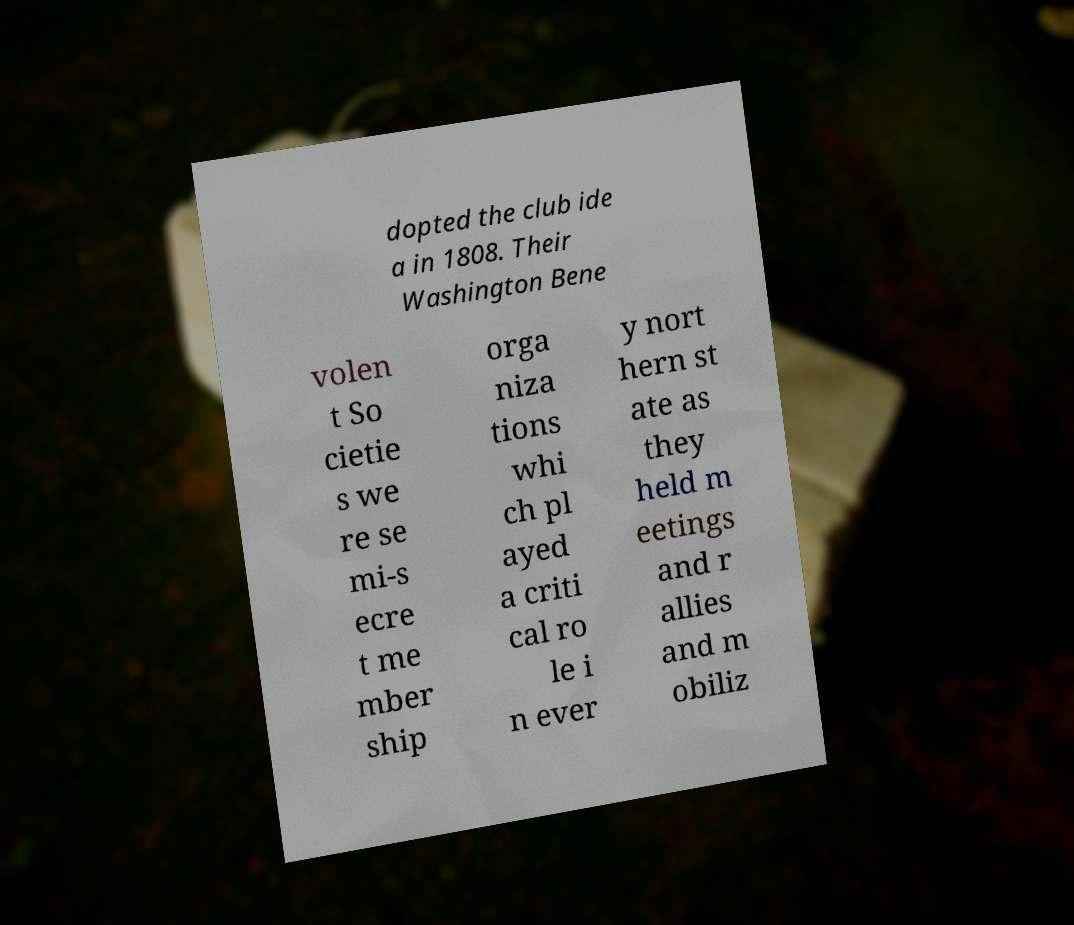For documentation purposes, I need the text within this image transcribed. Could you provide that? dopted the club ide a in 1808. Their Washington Bene volen t So cietie s we re se mi-s ecre t me mber ship orga niza tions whi ch pl ayed a criti cal ro le i n ever y nort hern st ate as they held m eetings and r allies and m obiliz 